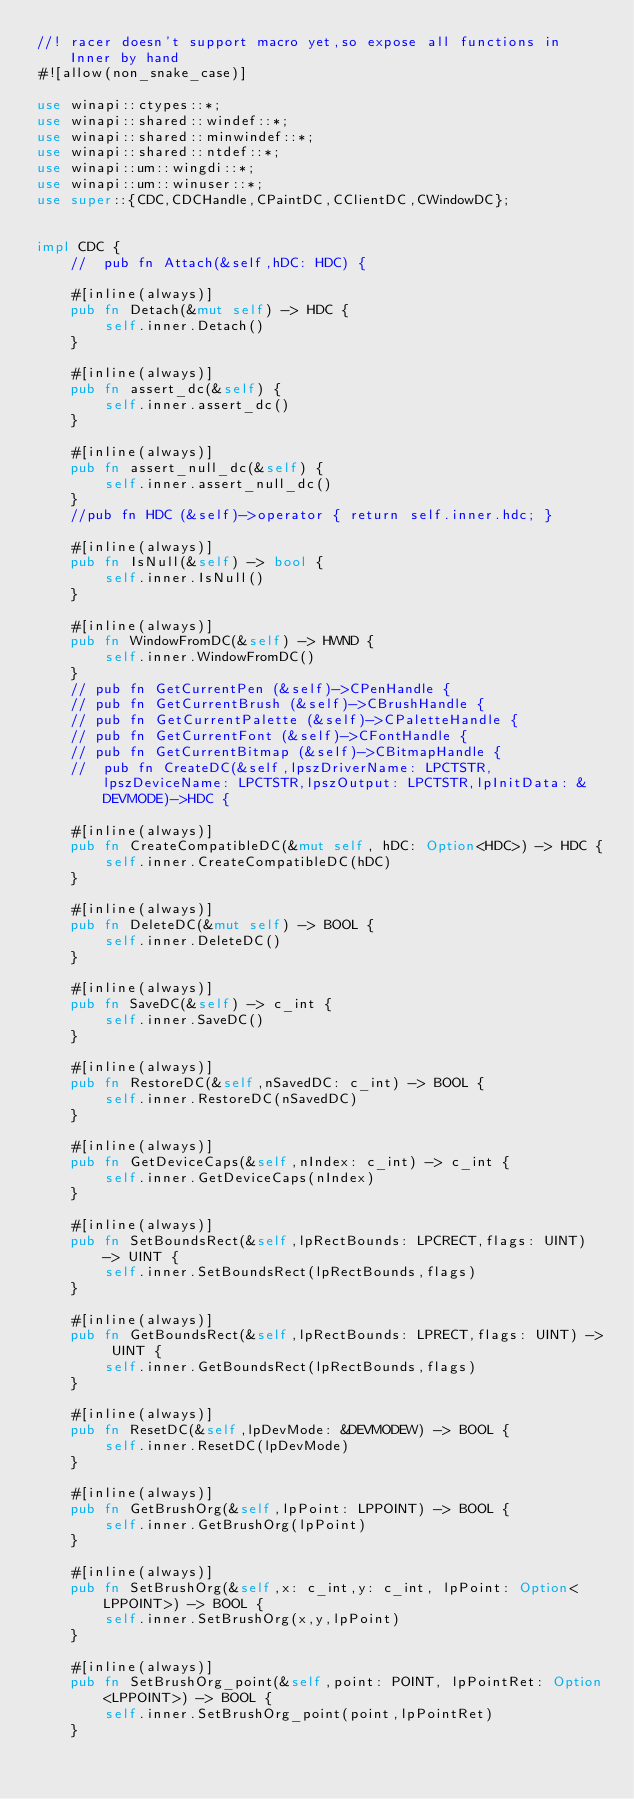Convert code to text. <code><loc_0><loc_0><loc_500><loc_500><_Rust_>//! racer doesn't support macro yet,so expose all functions in Inner by hand
#![allow(non_snake_case)]

use winapi::ctypes::*;
use winapi::shared::windef::*;
use winapi::shared::minwindef::*;
use winapi::shared::ntdef::*;
use winapi::um::wingdi::*;
use winapi::um::winuser::*;
use super::{CDC,CDCHandle,CPaintDC,CClientDC,CWindowDC};


impl CDC {
	//  pub fn Attach(&self,hDC: HDC) {

	#[inline(always)]
	pub fn Detach(&mut self) -> HDC {
		self.inner.Detach()
	}

	#[inline(always)]
	pub fn assert_dc(&self) {
		self.inner.assert_dc()
	}

	#[inline(always)]
	pub fn assert_null_dc(&self) {
		self.inner.assert_null_dc()
	}
	//pub fn HDC (&self)->operator { return self.inner.hdc; }

	#[inline(always)]
	pub fn IsNull(&self) -> bool {
		self.inner.IsNull()
	}

	#[inline(always)]
	pub fn WindowFromDC(&self) -> HWND {
		self.inner.WindowFromDC()
	}
	// pub fn GetCurrentPen (&self)->CPenHandle {
	// pub fn GetCurrentBrush (&self)->CBrushHandle {
	// pub fn GetCurrentPalette (&self)->CPaletteHandle {
	// pub fn GetCurrentFont (&self)->CFontHandle {
	// pub fn GetCurrentBitmap (&self)->CBitmapHandle {
	//  pub fn CreateDC(&self,lpszDriverName: LPCTSTR,lpszDeviceName: LPCTSTR,lpszOutput: LPCTSTR,lpInitData: &DEVMODE)->HDC {

	#[inline(always)]
	pub fn CreateCompatibleDC(&mut self, hDC: Option<HDC>) -> HDC {
		self.inner.CreateCompatibleDC(hDC)
	}

	#[inline(always)]
	pub fn DeleteDC(&mut self) -> BOOL {
		self.inner.DeleteDC()
	}

	#[inline(always)]
	pub fn SaveDC(&self) -> c_int {
		self.inner.SaveDC()
	}

	#[inline(always)]
	pub fn RestoreDC(&self,nSavedDC: c_int) -> BOOL {
		self.inner.RestoreDC(nSavedDC)
	}

	#[inline(always)]
	pub fn GetDeviceCaps(&self,nIndex: c_int) -> c_int {
		self.inner.GetDeviceCaps(nIndex)
	}

	#[inline(always)]
	pub fn SetBoundsRect(&self,lpRectBounds: LPCRECT,flags: UINT) -> UINT {
		self.inner.SetBoundsRect(lpRectBounds,flags)
	}

	#[inline(always)]
	pub fn GetBoundsRect(&self,lpRectBounds: LPRECT,flags: UINT) -> UINT {
		self.inner.GetBoundsRect(lpRectBounds,flags)
	}

	#[inline(always)]
	pub fn ResetDC(&self,lpDevMode: &DEVMODEW) -> BOOL {
		self.inner.ResetDC(lpDevMode)
	}

	#[inline(always)]
	pub fn GetBrushOrg(&self,lpPoint: LPPOINT) -> BOOL {
		self.inner.GetBrushOrg(lpPoint)
	}

	#[inline(always)]
	pub fn SetBrushOrg(&self,x: c_int,y: c_int, lpPoint: Option<LPPOINT>) -> BOOL {
		self.inner.SetBrushOrg(x,y,lpPoint)
	}

	#[inline(always)]
	pub fn SetBrushOrg_point(&self,point: POINT, lpPointRet: Option<LPPOINT>) -> BOOL {
		self.inner.SetBrushOrg_point(point,lpPointRet)
	}</code> 